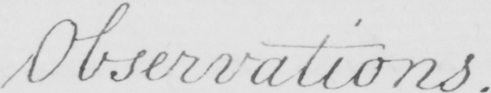What text is written in this handwritten line? Observations 